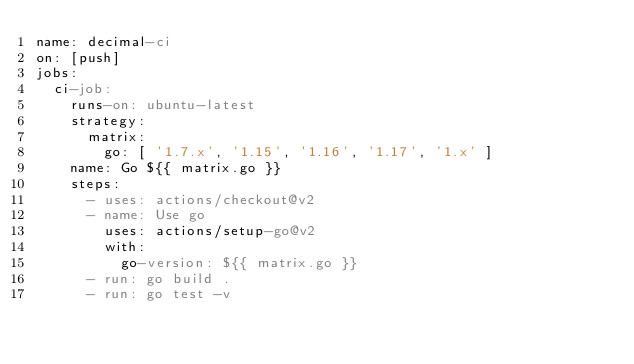Convert code to text. <code><loc_0><loc_0><loc_500><loc_500><_YAML_>name: decimal-ci
on: [push]
jobs:
  ci-job:
    runs-on: ubuntu-latest
    strategy:
      matrix:
        go: [ '1.7.x', '1.15', '1.16', '1.17', '1.x' ]
    name: Go ${{ matrix.go }}
    steps:
      - uses: actions/checkout@v2
      - name: Use go
        uses: actions/setup-go@v2
        with:
          go-version: ${{ matrix.go }}
      - run: go build .
      - run: go test -v
</code> 